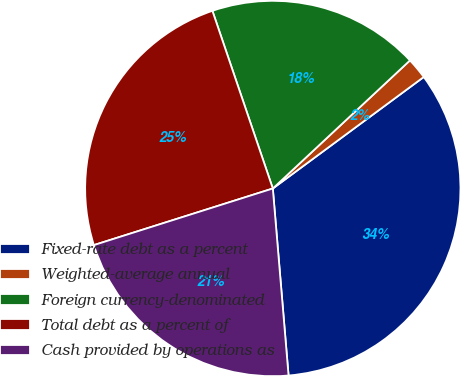Convert chart to OTSL. <chart><loc_0><loc_0><loc_500><loc_500><pie_chart><fcel>Fixed-rate debt as a percent<fcel>Weighted-average annual<fcel>Foreign currency-denominated<fcel>Total debt as a percent of<fcel>Cash provided by operations as<nl><fcel>33.79%<fcel>1.83%<fcel>18.26%<fcel>24.66%<fcel>21.46%<nl></chart> 